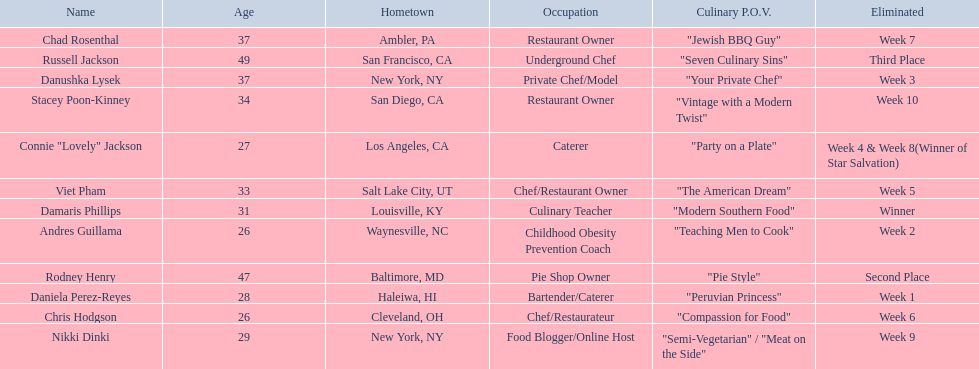Who are all of the contestants? Damaris Phillips, Rodney Henry, Russell Jackson, Stacey Poon-Kinney, Nikki Dinki, Chad Rosenthal, Chris Hodgson, Viet Pham, Connie "Lovely" Jackson, Danushka Lysek, Andres Guillama, Daniela Perez-Reyes. What is each player's culinary point of view? "Modern Southern Food", "Pie Style", "Seven Culinary Sins", "Vintage with a Modern Twist", "Semi-Vegetarian" / "Meat on the Side", "Jewish BBQ Guy", "Compassion for Food", "The American Dream", "Party on a Plate", "Your Private Chef", "Teaching Men to Cook", "Peruvian Princess". And which player's point of view is the longest? Nikki Dinki. 